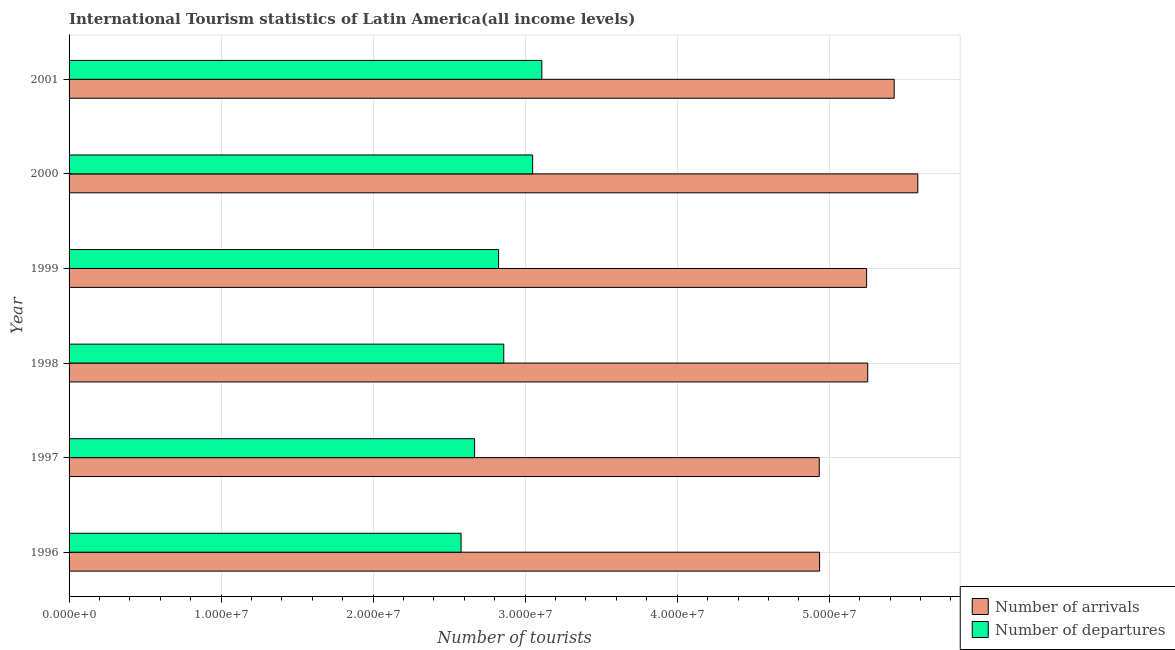How many different coloured bars are there?
Give a very brief answer. 2. How many groups of bars are there?
Provide a short and direct response. 6. Are the number of bars per tick equal to the number of legend labels?
Offer a very short reply. Yes. Are the number of bars on each tick of the Y-axis equal?
Provide a succinct answer. Yes. What is the label of the 1st group of bars from the top?
Make the answer very short. 2001. What is the number of tourist departures in 2001?
Your response must be concise. 3.11e+07. Across all years, what is the maximum number of tourist departures?
Ensure brevity in your answer.  3.11e+07. Across all years, what is the minimum number of tourist departures?
Make the answer very short. 2.58e+07. In which year was the number of tourist departures maximum?
Offer a very short reply. 2001. In which year was the number of tourist departures minimum?
Keep it short and to the point. 1996. What is the total number of tourist arrivals in the graph?
Provide a short and direct response. 3.14e+08. What is the difference between the number of tourist departures in 1997 and that in 2000?
Keep it short and to the point. -3.82e+06. What is the difference between the number of tourist departures in 1999 and the number of tourist arrivals in 1996?
Offer a very short reply. -2.11e+07. What is the average number of tourist arrivals per year?
Offer a terse response. 5.23e+07. In the year 2001, what is the difference between the number of tourist arrivals and number of tourist departures?
Your answer should be compact. 2.32e+07. In how many years, is the number of tourist arrivals greater than 6000000 ?
Your answer should be very brief. 6. What is the difference between the highest and the second highest number of tourist departures?
Your answer should be compact. 6.03e+05. What is the difference between the highest and the lowest number of tourist departures?
Offer a terse response. 5.31e+06. In how many years, is the number of tourist departures greater than the average number of tourist departures taken over all years?
Give a very brief answer. 3. What does the 2nd bar from the top in 1998 represents?
Offer a very short reply. Number of arrivals. What does the 1st bar from the bottom in 1999 represents?
Your response must be concise. Number of arrivals. How many bars are there?
Your answer should be compact. 12. Are all the bars in the graph horizontal?
Make the answer very short. Yes. How many years are there in the graph?
Your response must be concise. 6. What is the difference between two consecutive major ticks on the X-axis?
Provide a short and direct response. 1.00e+07. Are the values on the major ticks of X-axis written in scientific E-notation?
Your answer should be compact. Yes. Does the graph contain any zero values?
Keep it short and to the point. No. Does the graph contain grids?
Give a very brief answer. Yes. Where does the legend appear in the graph?
Your response must be concise. Bottom right. How are the legend labels stacked?
Ensure brevity in your answer.  Vertical. What is the title of the graph?
Your response must be concise. International Tourism statistics of Latin America(all income levels). What is the label or title of the X-axis?
Offer a very short reply. Number of tourists. What is the label or title of the Y-axis?
Offer a terse response. Year. What is the Number of tourists in Number of arrivals in 1996?
Provide a short and direct response. 4.94e+07. What is the Number of tourists in Number of departures in 1996?
Make the answer very short. 2.58e+07. What is the Number of tourists in Number of arrivals in 1997?
Keep it short and to the point. 4.93e+07. What is the Number of tourists in Number of departures in 1997?
Offer a terse response. 2.67e+07. What is the Number of tourists of Number of arrivals in 1998?
Provide a short and direct response. 5.25e+07. What is the Number of tourists in Number of departures in 1998?
Your answer should be compact. 2.86e+07. What is the Number of tourists in Number of arrivals in 1999?
Your response must be concise. 5.25e+07. What is the Number of tourists in Number of departures in 1999?
Offer a terse response. 2.83e+07. What is the Number of tourists in Number of arrivals in 2000?
Make the answer very short. 5.58e+07. What is the Number of tourists of Number of departures in 2000?
Give a very brief answer. 3.05e+07. What is the Number of tourists of Number of arrivals in 2001?
Your answer should be compact. 5.43e+07. What is the Number of tourists in Number of departures in 2001?
Ensure brevity in your answer.  3.11e+07. Across all years, what is the maximum Number of tourists of Number of arrivals?
Provide a succinct answer. 5.58e+07. Across all years, what is the maximum Number of tourists in Number of departures?
Provide a succinct answer. 3.11e+07. Across all years, what is the minimum Number of tourists of Number of arrivals?
Give a very brief answer. 4.93e+07. Across all years, what is the minimum Number of tourists in Number of departures?
Keep it short and to the point. 2.58e+07. What is the total Number of tourists of Number of arrivals in the graph?
Provide a short and direct response. 3.14e+08. What is the total Number of tourists in Number of departures in the graph?
Your answer should be compact. 1.71e+08. What is the difference between the Number of tourists of Number of arrivals in 1996 and that in 1997?
Ensure brevity in your answer.  2.15e+04. What is the difference between the Number of tourists of Number of departures in 1996 and that in 1997?
Your answer should be very brief. -8.90e+05. What is the difference between the Number of tourists of Number of arrivals in 1996 and that in 1998?
Make the answer very short. -3.17e+06. What is the difference between the Number of tourists in Number of departures in 1996 and that in 1998?
Keep it short and to the point. -2.81e+06. What is the difference between the Number of tourists in Number of arrivals in 1996 and that in 1999?
Make the answer very short. -3.09e+06. What is the difference between the Number of tourists of Number of departures in 1996 and that in 1999?
Ensure brevity in your answer.  -2.47e+06. What is the difference between the Number of tourists of Number of arrivals in 1996 and that in 2000?
Offer a terse response. -6.46e+06. What is the difference between the Number of tourists in Number of departures in 1996 and that in 2000?
Offer a very short reply. -4.71e+06. What is the difference between the Number of tourists in Number of arrivals in 1996 and that in 2001?
Your answer should be compact. -4.91e+06. What is the difference between the Number of tourists in Number of departures in 1996 and that in 2001?
Offer a very short reply. -5.31e+06. What is the difference between the Number of tourists of Number of arrivals in 1997 and that in 1998?
Offer a very short reply. -3.19e+06. What is the difference between the Number of tourists of Number of departures in 1997 and that in 1998?
Provide a short and direct response. -1.92e+06. What is the difference between the Number of tourists in Number of arrivals in 1997 and that in 1999?
Your answer should be compact. -3.12e+06. What is the difference between the Number of tourists of Number of departures in 1997 and that in 1999?
Keep it short and to the point. -1.58e+06. What is the difference between the Number of tourists in Number of arrivals in 1997 and that in 2000?
Provide a succinct answer. -6.48e+06. What is the difference between the Number of tourists in Number of departures in 1997 and that in 2000?
Offer a very short reply. -3.82e+06. What is the difference between the Number of tourists in Number of arrivals in 1997 and that in 2001?
Your answer should be very brief. -4.93e+06. What is the difference between the Number of tourists of Number of departures in 1997 and that in 2001?
Offer a terse response. -4.42e+06. What is the difference between the Number of tourists in Number of arrivals in 1998 and that in 1999?
Your answer should be very brief. 7.27e+04. What is the difference between the Number of tourists of Number of departures in 1998 and that in 1999?
Your answer should be compact. 3.40e+05. What is the difference between the Number of tourists in Number of arrivals in 1998 and that in 2000?
Offer a terse response. -3.29e+06. What is the difference between the Number of tourists in Number of departures in 1998 and that in 2000?
Give a very brief answer. -1.90e+06. What is the difference between the Number of tourists of Number of arrivals in 1998 and that in 2001?
Give a very brief answer. -1.74e+06. What is the difference between the Number of tourists in Number of departures in 1998 and that in 2001?
Your answer should be compact. -2.50e+06. What is the difference between the Number of tourists of Number of arrivals in 1999 and that in 2000?
Your answer should be very brief. -3.37e+06. What is the difference between the Number of tourists in Number of departures in 1999 and that in 2000?
Make the answer very short. -2.24e+06. What is the difference between the Number of tourists in Number of arrivals in 1999 and that in 2001?
Your answer should be very brief. -1.81e+06. What is the difference between the Number of tourists in Number of departures in 1999 and that in 2001?
Your answer should be compact. -2.84e+06. What is the difference between the Number of tourists of Number of arrivals in 2000 and that in 2001?
Make the answer very short. 1.55e+06. What is the difference between the Number of tourists of Number of departures in 2000 and that in 2001?
Make the answer very short. -6.03e+05. What is the difference between the Number of tourists of Number of arrivals in 1996 and the Number of tourists of Number of departures in 1997?
Keep it short and to the point. 2.27e+07. What is the difference between the Number of tourists in Number of arrivals in 1996 and the Number of tourists in Number of departures in 1998?
Provide a short and direct response. 2.08e+07. What is the difference between the Number of tourists of Number of arrivals in 1996 and the Number of tourists of Number of departures in 1999?
Offer a very short reply. 2.11e+07. What is the difference between the Number of tourists in Number of arrivals in 1996 and the Number of tourists in Number of departures in 2000?
Make the answer very short. 1.89e+07. What is the difference between the Number of tourists in Number of arrivals in 1996 and the Number of tourists in Number of departures in 2001?
Your response must be concise. 1.83e+07. What is the difference between the Number of tourists in Number of arrivals in 1997 and the Number of tourists in Number of departures in 1998?
Provide a succinct answer. 2.08e+07. What is the difference between the Number of tourists in Number of arrivals in 1997 and the Number of tourists in Number of departures in 1999?
Give a very brief answer. 2.11e+07. What is the difference between the Number of tourists of Number of arrivals in 1997 and the Number of tourists of Number of departures in 2000?
Your answer should be compact. 1.89e+07. What is the difference between the Number of tourists in Number of arrivals in 1997 and the Number of tourists in Number of departures in 2001?
Keep it short and to the point. 1.82e+07. What is the difference between the Number of tourists in Number of arrivals in 1998 and the Number of tourists in Number of departures in 1999?
Your response must be concise. 2.43e+07. What is the difference between the Number of tourists of Number of arrivals in 1998 and the Number of tourists of Number of departures in 2000?
Keep it short and to the point. 2.20e+07. What is the difference between the Number of tourists of Number of arrivals in 1998 and the Number of tourists of Number of departures in 2001?
Keep it short and to the point. 2.14e+07. What is the difference between the Number of tourists of Number of arrivals in 1999 and the Number of tourists of Number of departures in 2000?
Your answer should be compact. 2.20e+07. What is the difference between the Number of tourists in Number of arrivals in 1999 and the Number of tourists in Number of departures in 2001?
Give a very brief answer. 2.14e+07. What is the difference between the Number of tourists of Number of arrivals in 2000 and the Number of tourists of Number of departures in 2001?
Offer a terse response. 2.47e+07. What is the average Number of tourists of Number of arrivals per year?
Offer a very short reply. 5.23e+07. What is the average Number of tourists in Number of departures per year?
Your answer should be very brief. 2.85e+07. In the year 1996, what is the difference between the Number of tourists in Number of arrivals and Number of tourists in Number of departures?
Your response must be concise. 2.36e+07. In the year 1997, what is the difference between the Number of tourists of Number of arrivals and Number of tourists of Number of departures?
Offer a terse response. 2.27e+07. In the year 1998, what is the difference between the Number of tourists of Number of arrivals and Number of tourists of Number of departures?
Ensure brevity in your answer.  2.39e+07. In the year 1999, what is the difference between the Number of tourists of Number of arrivals and Number of tourists of Number of departures?
Make the answer very short. 2.42e+07. In the year 2000, what is the difference between the Number of tourists in Number of arrivals and Number of tourists in Number of departures?
Provide a short and direct response. 2.53e+07. In the year 2001, what is the difference between the Number of tourists of Number of arrivals and Number of tourists of Number of departures?
Keep it short and to the point. 2.32e+07. What is the ratio of the Number of tourists in Number of departures in 1996 to that in 1997?
Make the answer very short. 0.97. What is the ratio of the Number of tourists of Number of arrivals in 1996 to that in 1998?
Offer a very short reply. 0.94. What is the ratio of the Number of tourists in Number of departures in 1996 to that in 1998?
Keep it short and to the point. 0.9. What is the ratio of the Number of tourists in Number of arrivals in 1996 to that in 1999?
Keep it short and to the point. 0.94. What is the ratio of the Number of tourists in Number of departures in 1996 to that in 1999?
Offer a terse response. 0.91. What is the ratio of the Number of tourists of Number of arrivals in 1996 to that in 2000?
Your answer should be compact. 0.88. What is the ratio of the Number of tourists in Number of departures in 1996 to that in 2000?
Give a very brief answer. 0.85. What is the ratio of the Number of tourists in Number of arrivals in 1996 to that in 2001?
Your answer should be very brief. 0.91. What is the ratio of the Number of tourists in Number of departures in 1996 to that in 2001?
Make the answer very short. 0.83. What is the ratio of the Number of tourists in Number of arrivals in 1997 to that in 1998?
Give a very brief answer. 0.94. What is the ratio of the Number of tourists in Number of departures in 1997 to that in 1998?
Keep it short and to the point. 0.93. What is the ratio of the Number of tourists in Number of arrivals in 1997 to that in 1999?
Your response must be concise. 0.94. What is the ratio of the Number of tourists in Number of departures in 1997 to that in 1999?
Provide a short and direct response. 0.94. What is the ratio of the Number of tourists of Number of arrivals in 1997 to that in 2000?
Your answer should be compact. 0.88. What is the ratio of the Number of tourists of Number of departures in 1997 to that in 2000?
Your answer should be compact. 0.87. What is the ratio of the Number of tourists of Number of arrivals in 1997 to that in 2001?
Make the answer very short. 0.91. What is the ratio of the Number of tourists in Number of departures in 1997 to that in 2001?
Your response must be concise. 0.86. What is the ratio of the Number of tourists in Number of arrivals in 1998 to that in 1999?
Ensure brevity in your answer.  1. What is the ratio of the Number of tourists of Number of departures in 1998 to that in 1999?
Your response must be concise. 1.01. What is the ratio of the Number of tourists of Number of arrivals in 1998 to that in 2000?
Give a very brief answer. 0.94. What is the ratio of the Number of tourists in Number of departures in 1998 to that in 2000?
Give a very brief answer. 0.94. What is the ratio of the Number of tourists in Number of arrivals in 1998 to that in 2001?
Offer a terse response. 0.97. What is the ratio of the Number of tourists in Number of departures in 1998 to that in 2001?
Give a very brief answer. 0.92. What is the ratio of the Number of tourists of Number of arrivals in 1999 to that in 2000?
Your response must be concise. 0.94. What is the ratio of the Number of tourists in Number of departures in 1999 to that in 2000?
Offer a very short reply. 0.93. What is the ratio of the Number of tourists in Number of arrivals in 1999 to that in 2001?
Give a very brief answer. 0.97. What is the ratio of the Number of tourists of Number of departures in 1999 to that in 2001?
Your answer should be compact. 0.91. What is the ratio of the Number of tourists of Number of arrivals in 2000 to that in 2001?
Ensure brevity in your answer.  1.03. What is the ratio of the Number of tourists in Number of departures in 2000 to that in 2001?
Provide a short and direct response. 0.98. What is the difference between the highest and the second highest Number of tourists of Number of arrivals?
Your answer should be very brief. 1.55e+06. What is the difference between the highest and the second highest Number of tourists of Number of departures?
Offer a very short reply. 6.03e+05. What is the difference between the highest and the lowest Number of tourists of Number of arrivals?
Offer a terse response. 6.48e+06. What is the difference between the highest and the lowest Number of tourists of Number of departures?
Give a very brief answer. 5.31e+06. 